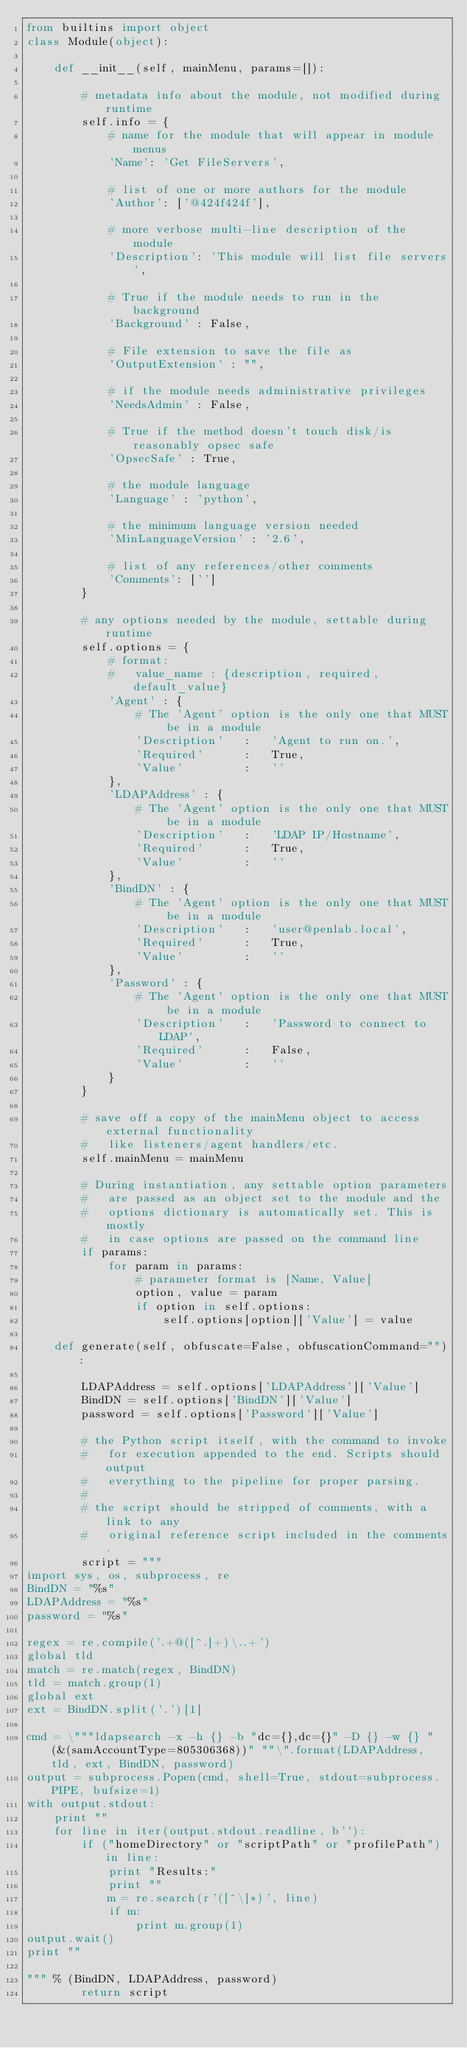Convert code to text. <code><loc_0><loc_0><loc_500><loc_500><_Python_>from builtins import object
class Module(object):

    def __init__(self, mainMenu, params=[]):

        # metadata info about the module, not modified during runtime
        self.info = {
            # name for the module that will appear in module menus
            'Name': 'Get FileServers',

            # list of one or more authors for the module
            'Author': ['@424f424f'],

            # more verbose multi-line description of the module
            'Description': 'This module will list file servers',

            # True if the module needs to run in the background
            'Background' : False,

            # File extension to save the file as
            'OutputExtension' : "",

            # if the module needs administrative privileges
            'NeedsAdmin' : False,

            # True if the method doesn't touch disk/is reasonably opsec safe
            'OpsecSafe' : True,

            # the module language
            'Language' : 'python',

            # the minimum language version needed
            'MinLanguageVersion' : '2.6',

            # list of any references/other comments
            'Comments': ['']
        }

        # any options needed by the module, settable during runtime
        self.options = {
            # format:
            #   value_name : {description, required, default_value}
            'Agent' : {
                # The 'Agent' option is the only one that MUST be in a module
                'Description'   :   'Agent to run on.',
                'Required'      :   True,
                'Value'         :   ''
            },
            'LDAPAddress' : {
                # The 'Agent' option is the only one that MUST be in a module
                'Description'   :   'LDAP IP/Hostname',
                'Required'      :   True,
                'Value'         :   ''
            },
            'BindDN' : {
                # The 'Agent' option is the only one that MUST be in a module
                'Description'   :   'user@penlab.local',
                'Required'      :   True,
                'Value'         :   ''
            },
            'Password' : {
                # The 'Agent' option is the only one that MUST be in a module
                'Description'   :   'Password to connect to LDAP',
                'Required'      :   False,
                'Value'         :   ''
            }
        }

        # save off a copy of the mainMenu object to access external functionality
        #   like listeners/agent handlers/etc.
        self.mainMenu = mainMenu

        # During instantiation, any settable option parameters
        #   are passed as an object set to the module and the
        #   options dictionary is automatically set. This is mostly
        #   in case options are passed on the command line
        if params:
            for param in params:
                # parameter format is [Name, Value]
                option, value = param
                if option in self.options:
                    self.options[option]['Value'] = value

    def generate(self, obfuscate=False, obfuscationCommand=""):

        LDAPAddress = self.options['LDAPAddress']['Value']
        BindDN = self.options['BindDN']['Value']
        password = self.options['Password']['Value']

        # the Python script itself, with the command to invoke
        #   for execution appended to the end. Scripts should output
        #   everything to the pipeline for proper parsing.
        #
        # the script should be stripped of comments, with a link to any
        #   original reference script included in the comments.
        script = """
import sys, os, subprocess, re
BindDN = "%s"
LDAPAddress = "%s"
password = "%s"

regex = re.compile('.+@([^.]+)\..+')
global tld
match = re.match(regex, BindDN)
tld = match.group(1)
global ext
ext = BindDN.split('.')[1]

cmd = \"""ldapsearch -x -h {} -b "dc={},dc={}" -D {} -w {} "(&(samAccountType=805306368))" ""\".format(LDAPAddress, tld, ext, BindDN, password)
output = subprocess.Popen(cmd, shell=True, stdout=subprocess.PIPE, bufsize=1)
with output.stdout:
    print ""
    for line in iter(output.stdout.readline, b''):
        if ("homeDirectory" or "scriptPath" or "profilePath") in line:
            print "Results:"
            print ""
            m = re.search(r'([^\]*)', line)
            if m:
                print m.group(1)
output.wait()
print ""

""" % (BindDN, LDAPAddress, password)
        return script
</code> 